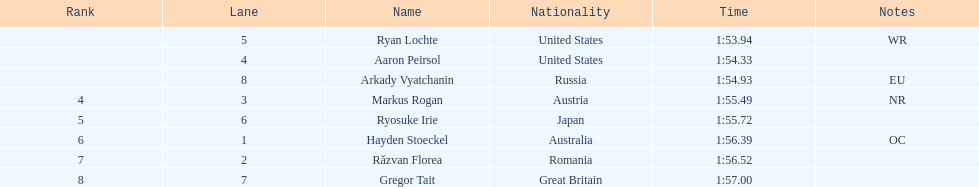Does russia or japan have the longer time? Japan. 